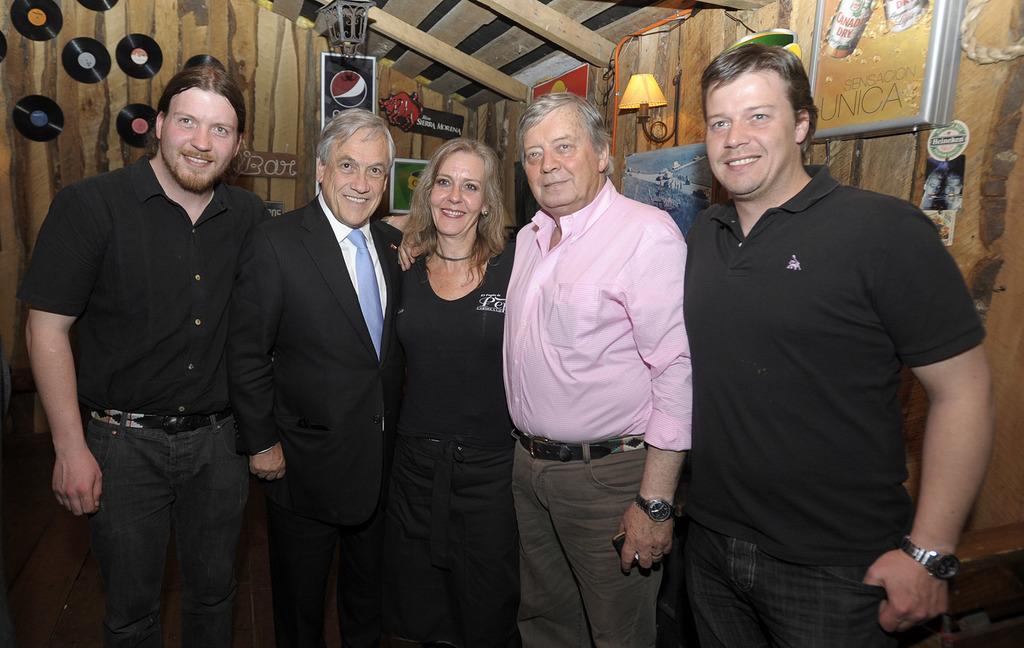Describe this image in one or two sentences. As we can see in the image there is wall, group of people standing, desks, lamp and posters. 